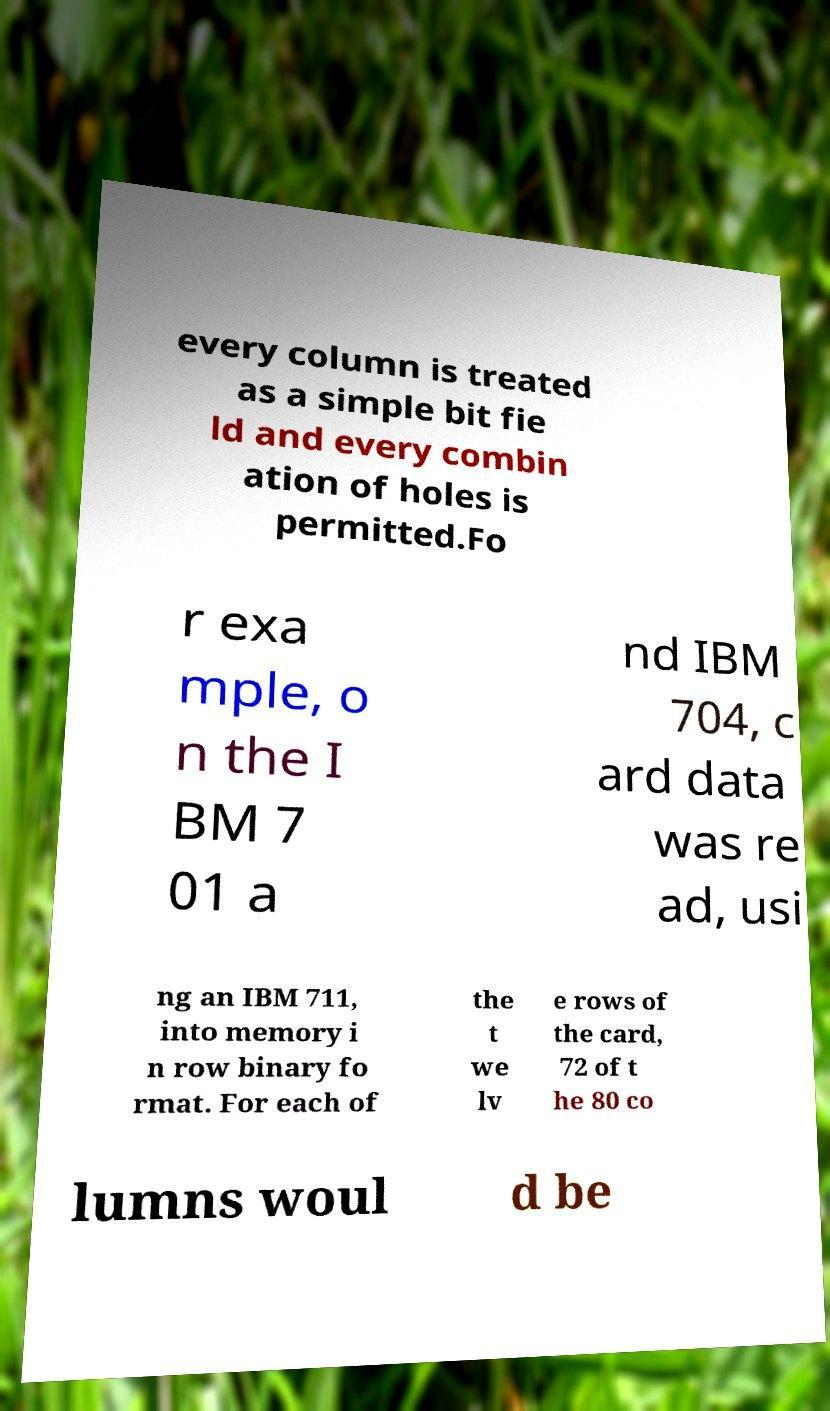I need the written content from this picture converted into text. Can you do that? every column is treated as a simple bit fie ld and every combin ation of holes is permitted.Fo r exa mple, o n the I BM 7 01 a nd IBM 704, c ard data was re ad, usi ng an IBM 711, into memory i n row binary fo rmat. For each of the t we lv e rows of the card, 72 of t he 80 co lumns woul d be 